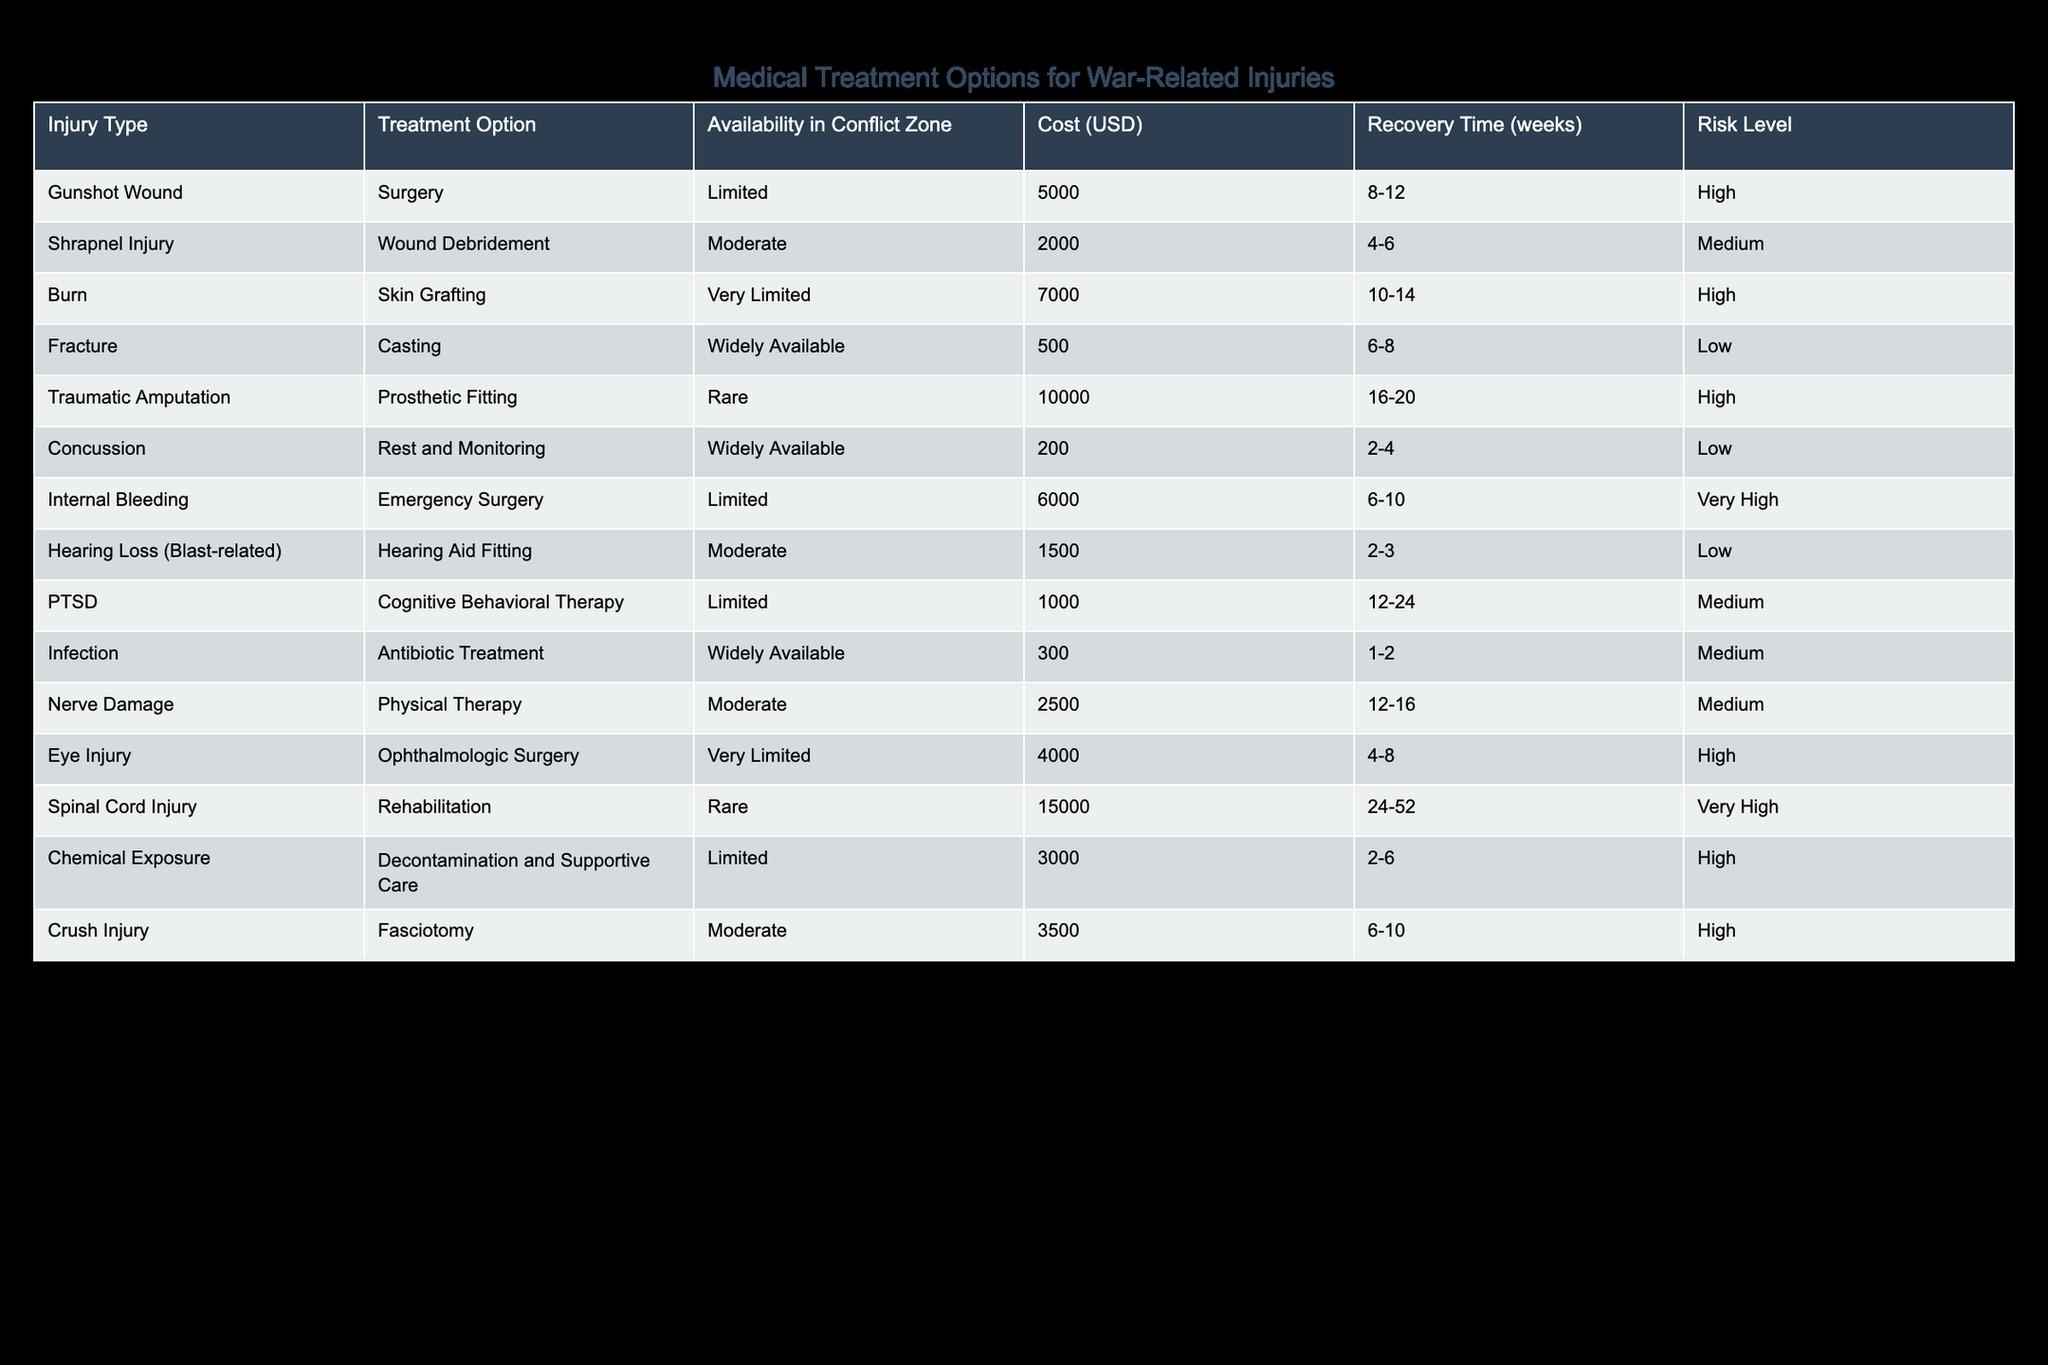What is the recovery time for a shrapnel injury? The recovery time for a shrapnel injury, as indicated in the table, is listed as 4 to 6 weeks.
Answer: 4-6 weeks Which treatment option is the most expensive? According to the data, the treatment option with the highest cost is "Spinal Cord Injury Rehabilitation," priced at 15,000 USD.
Answer: 15,000 USD Is casting widely available for fractures? Yes, the table shows that casting is widely available for fractures, indicating better accessibility for this treatment option.
Answer: Yes What is the average cost of treatments that have a high risk level? The treatments with a high risk level and their respective costs are: Gunshot Wound (5,000), Burn (7,000), Traumatic Amputation (10,000), Eye Injury (4,000), and Chemical Exposure (3,000). The sum of these costs is 5,000 + 7,000 + 10,000 + 4,000 + 3,000 = 29,000. There are 5 treatment options, so the average cost is 29,000 / 5 = 5,800 USD.
Answer: 5,800 USD How many weeks of recovery does a traumatic amputation require? The table outlines that the recovery time for a traumatic amputation is 16 to 20 weeks.
Answer: 16-20 weeks What is the risk level associated with rest and monitoring for concussion? The table indicates that the risk level for rest and monitoring for a concussion is low, making it a safer treatment option compared to others.
Answer: Low Which treatment option is available for internal bleeding and what is its cost? The only treatment option listed for internal bleeding is emergency surgery, which has a limited availability and costs 6,000 USD.
Answer: Emergency surgery, 6,000 USD How does the cost of skin grafting compare to antibiotic treatment? Skin grafting costs 7,000 USD while antibiotic treatment costs 300 USD. The difference in cost is 7,000 - 300 = 6,700 USD, showing that skin grafting is significantly more expensive than antibiotic treatment.
Answer: 6,700 USD Is hearing aid fitting available in the conflict zone? Yes, the table shows that hearing aid fitting is classified as moderately available, indicating that it is accessible but not as readily as widely available options.
Answer: Yes What treatment options are available for injuries with very high-risk levels? The treatments listed with very high-risk levels are internal bleeding (emergency surgery) and spinal cord injury (rehabilitation). These treatments imply increased chances of complications and demand careful consideration.
Answer: Emergency surgery, Rehabilitation 